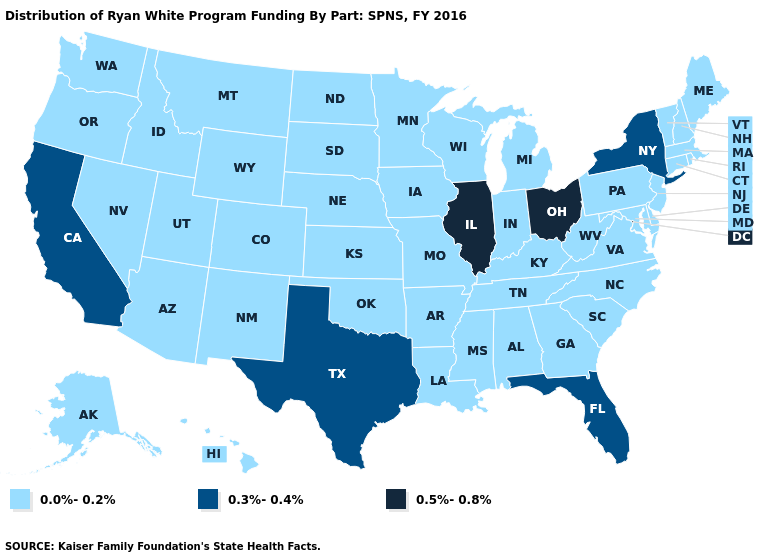What is the highest value in states that border California?
Write a very short answer. 0.0%-0.2%. What is the value of New Jersey?
Give a very brief answer. 0.0%-0.2%. What is the lowest value in states that border South Dakota?
Keep it brief. 0.0%-0.2%. Among the states that border North Dakota , which have the highest value?
Keep it brief. Minnesota, Montana, South Dakota. Which states have the lowest value in the Northeast?
Give a very brief answer. Connecticut, Maine, Massachusetts, New Hampshire, New Jersey, Pennsylvania, Rhode Island, Vermont. What is the value of Hawaii?
Short answer required. 0.0%-0.2%. What is the value of Texas?
Keep it brief. 0.3%-0.4%. Does Oregon have the same value as Rhode Island?
Keep it brief. Yes. Name the states that have a value in the range 0.5%-0.8%?
Short answer required. Illinois, Ohio. What is the value of New Mexico?
Be succinct. 0.0%-0.2%. Is the legend a continuous bar?
Concise answer only. No. Name the states that have a value in the range 0.3%-0.4%?
Keep it brief. California, Florida, New York, Texas. Is the legend a continuous bar?
Give a very brief answer. No. What is the value of South Carolina?
Concise answer only. 0.0%-0.2%. 